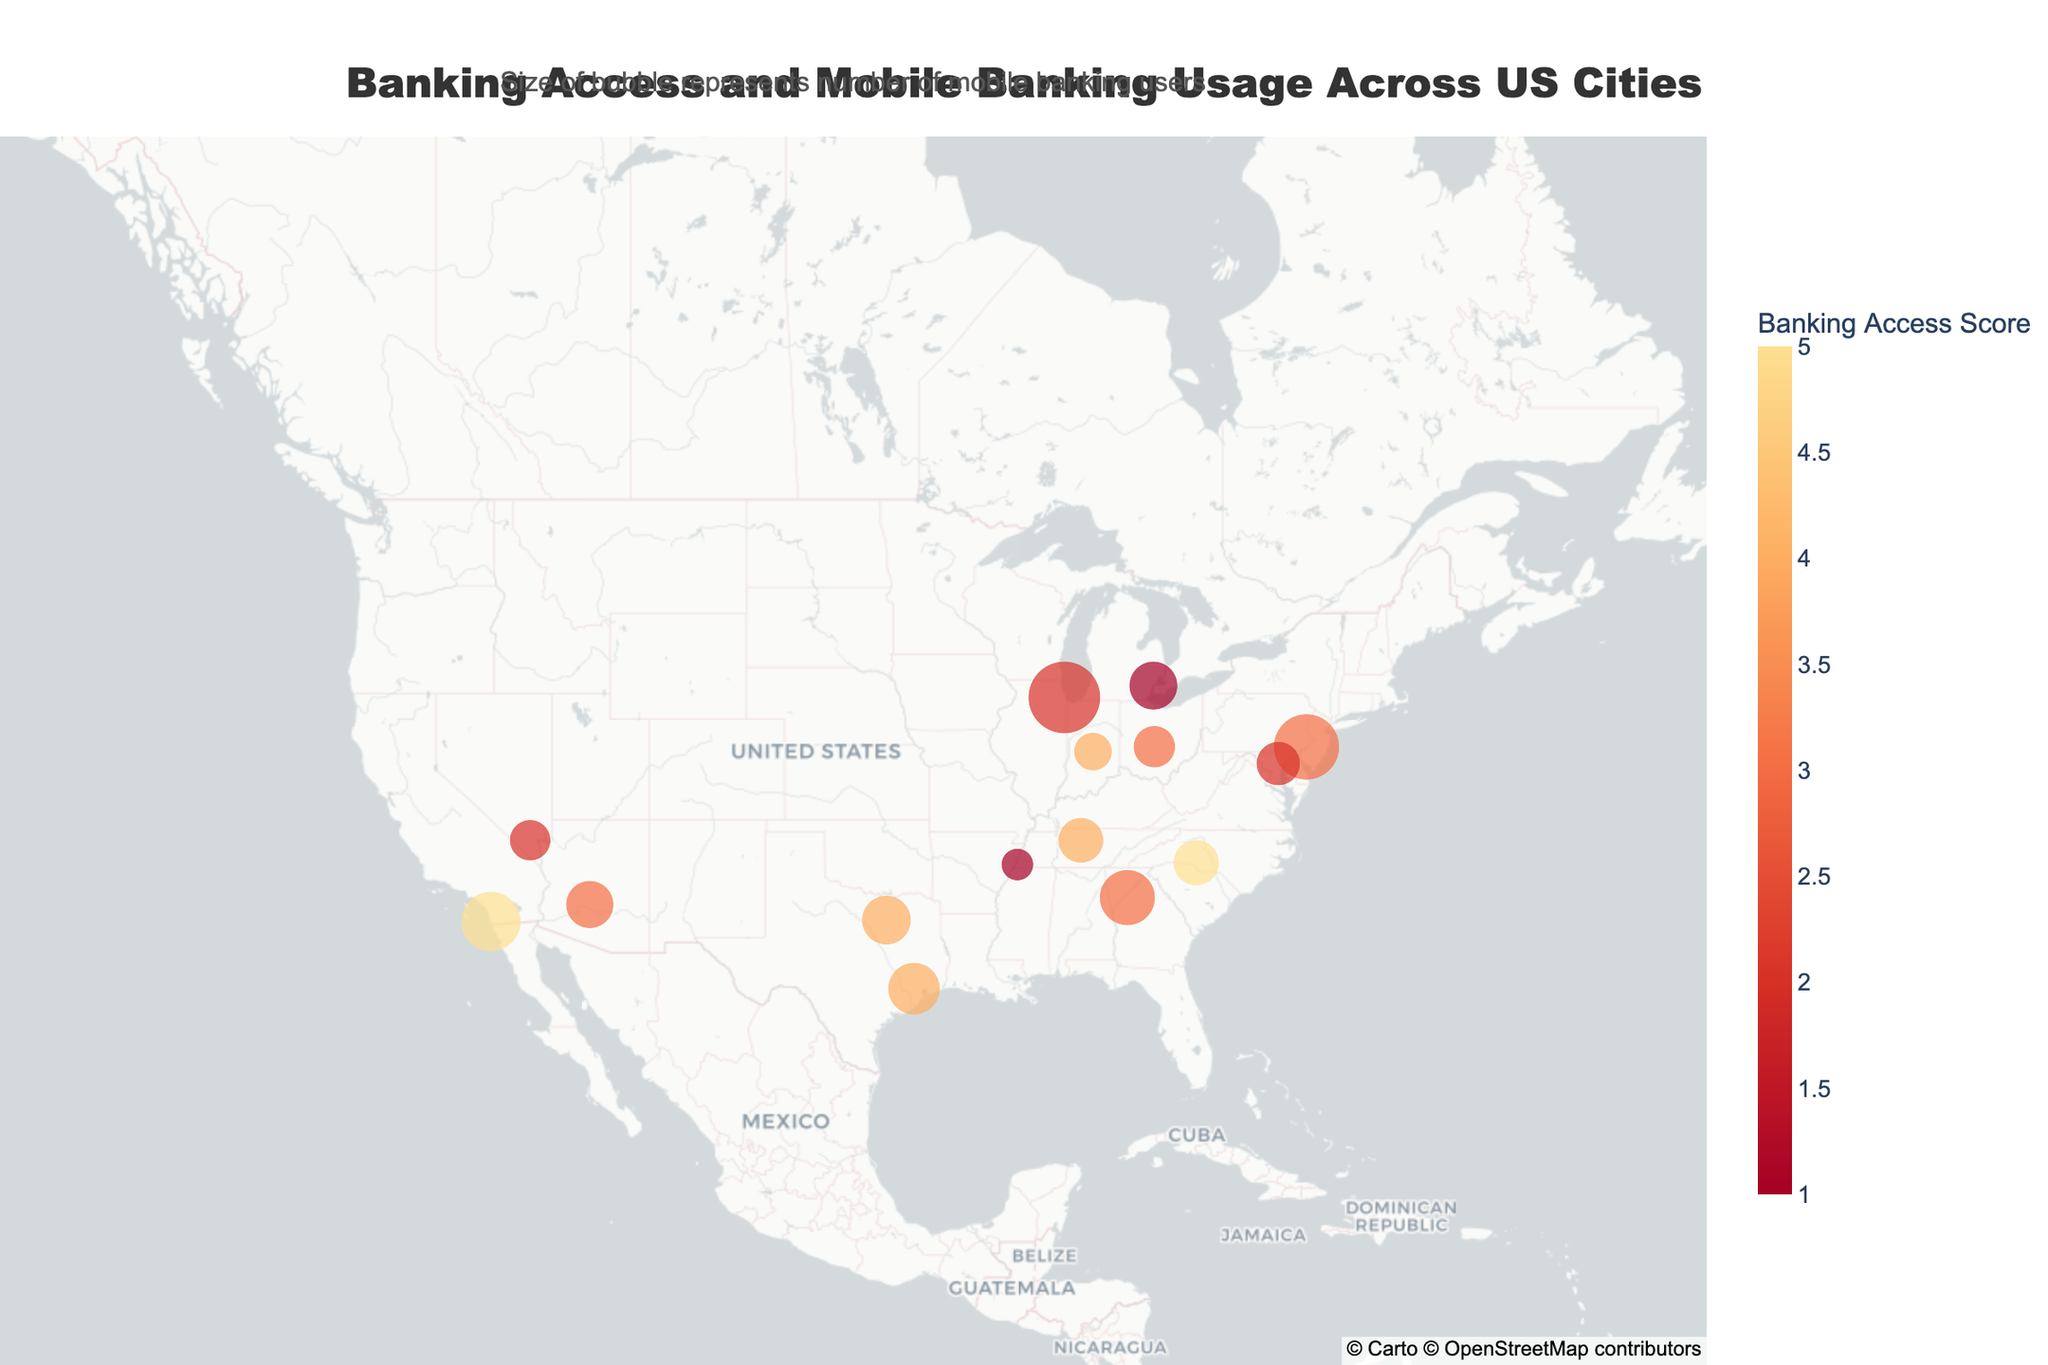what city has the highest banking access score? To find the city with the highest banking access score, check the data points on the map and identify the marker with the highest score. Charlotte, North Carolina, and San Diego, California, both have a score of 5.
Answer: Charlotte, North Carolina, and San Diego, California how many cities have a banking access score of 2? Check each data point on the map and count those with a banking access score of 2. There are three cities with a score of 2: Chicago, Illinois, Las Vegas, Nevada, and Baltimore, Maryland.
Answer: 3 which city has the highest number of mobile banking users? Look at the size of the markers to identify the city with the largest bubble. Chicago, Illinois has the largest bubble, indicating the highest number of mobile banking users, which is 2100.
Answer: Chicago, Illinois which state has the highest number of mobile banking users across all its cities in the plot? Sum the number of mobile banking users for each state. Georgia (Atlanta: 1250), Texas (Dallas: 980, Houston: 1100), Illinois (Chicago: 2100), Pennsylvania (Philadelphia: 1750), North Carolina (Charlotte: 850), Arizona (Phoenix: 920), Nevada (Las Vegas: 680), Indiana (Indianapolis: 590), California (San Diego: 1450), Maryland (Baltimore: 780), Tennessee (Memphis: 420, Nashville: 830), Michigan (Detroit: 950), Ohio (Columbus: 710). The state with the highest total is Illinois (2100).
Answer: Illinois which city with a banking access score of 3 has the most mobile banking users? Identify the cities with a banking access score of 3 and compare their mobile banking user counts. The cities are Atlanta, Georgia (1250), Philadelphia, Pennsylvania (1750), Phoenix, Arizona (920), and Columbus, Ohio (710). Philadelphia, Pennsylvania has the most mobile banking users.
Answer: Philadelphia, Pennsylvania what is the average banking access score across all cities? Sum the banking access scores for all cities and divide by the number of cities. The scores are: 3, 4, 2, 3, 5, 4, 3, 2, 4, 5, 2, 1, 1, 3, 4. The sum is 46 and there are 15 cities, so the average is 46/15 ≈ 3.07.
Answer: 3.07 which city has the smallest number of mobile banking users? Look for the smallest marker on the map to find the city with the lowest number of mobile banking users. Memphis, Tennessee has the smallest marker, indicating 420 users.
Answer: Memphis, Tennessee how does the banking access score correlate with mobile banking usage across the cities? Visually assess whether there is a pattern between the banking access scores and the size of the markers. Cities with lower banking access scores (such as 1 and 2) often have significant mobile banking usage as shown by larger marker sizes (e.g., Detroit, Memphis with lower scores but considerable usage). Conversely, some cities with higher scores (like Charlotte and San Diego with scores of 5) have smaller marker sizes. There appears to be a negative correlation where areas with limited banking access might rely more on mobile banking.
Answer: Negative correlation what trend can be observed about the geographic distribution of cities with low banking access scores? Examine the map to determine spatial patterns of low banking access scores (scores of 1 or 2). Cities with the lowest scores (1 or 2) are dispersed throughout the US, including Memphis, Tennessee, Detroit, Michigan, Las Vegas, Nevada, Chicago, Illinois, and Baltimore, Maryland. There is no strong regional concentration, indicating widespread issues.
Answer: Widespread distribution which cities have a banking access score lower than 4 and more than 1000 mobile banking users? Identify cities with a banking access score less than 4 and then check their mobile banking users. The cities are Atlanta, Georgia (1250 users), Chicago, Illinois (2100 users), Philadelphia, Pennsylvania (1750 users), Phoenix, Arizona (920 users), Las Vegas, Nevada (680 users), Baltimore, Maryland (780 users), Memphis, Tennessee (420 users), and Detroit, Michigan (950 users). Only Atlanta, Chicago, and Philadelphia meet both criteria.
Answer: Atlanta, Georgia; Chicago, Illinois; Philadelphia, Pennsylvania 